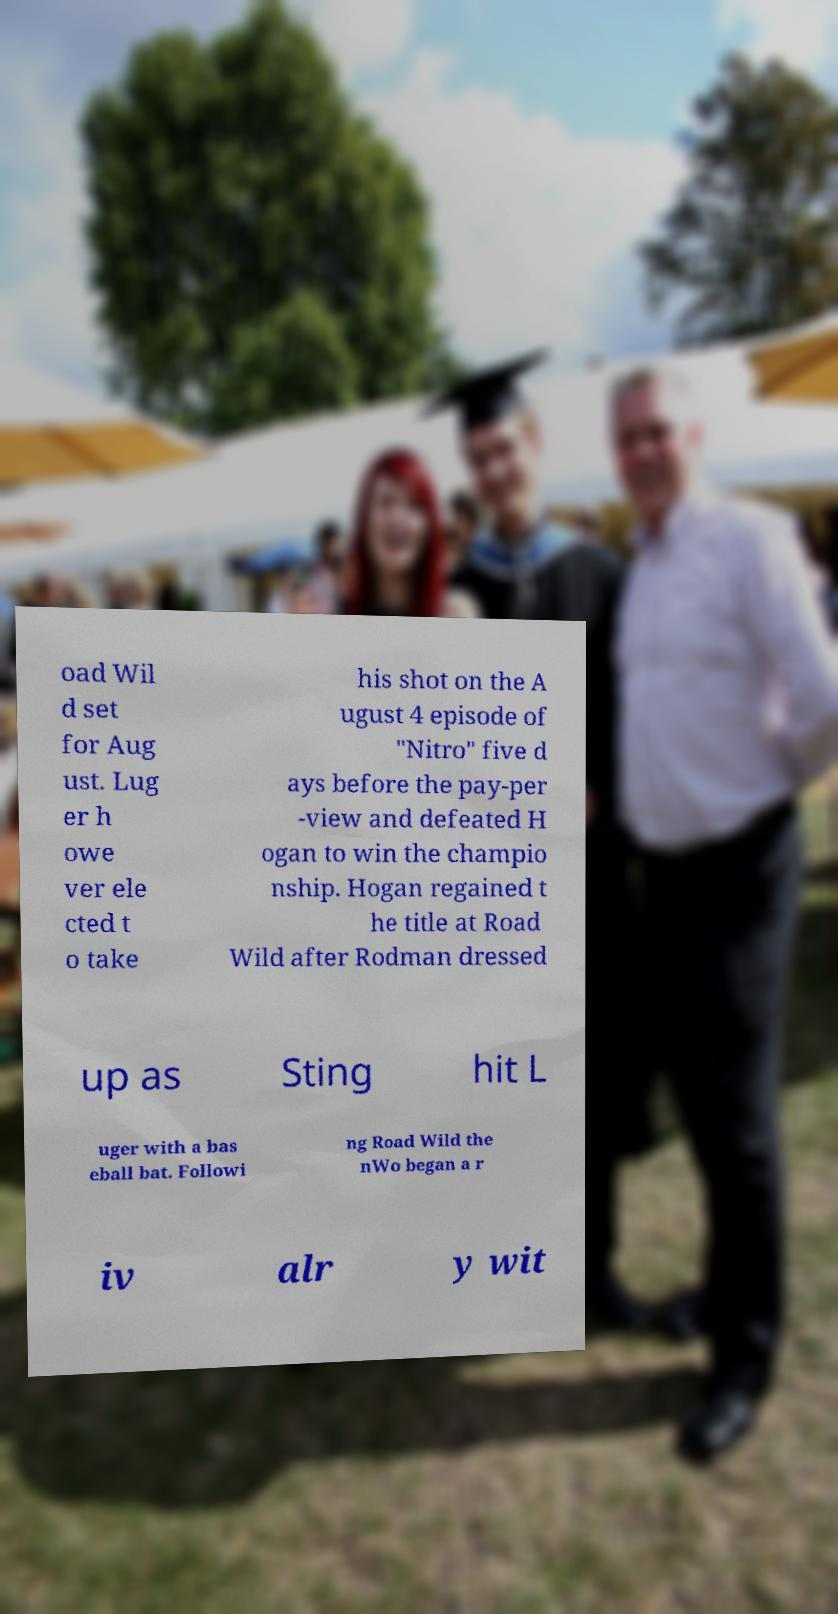There's text embedded in this image that I need extracted. Can you transcribe it verbatim? oad Wil d set for Aug ust. Lug er h owe ver ele cted t o take his shot on the A ugust 4 episode of "Nitro" five d ays before the pay-per -view and defeated H ogan to win the champio nship. Hogan regained t he title at Road Wild after Rodman dressed up as Sting hit L uger with a bas eball bat. Followi ng Road Wild the nWo began a r iv alr y wit 